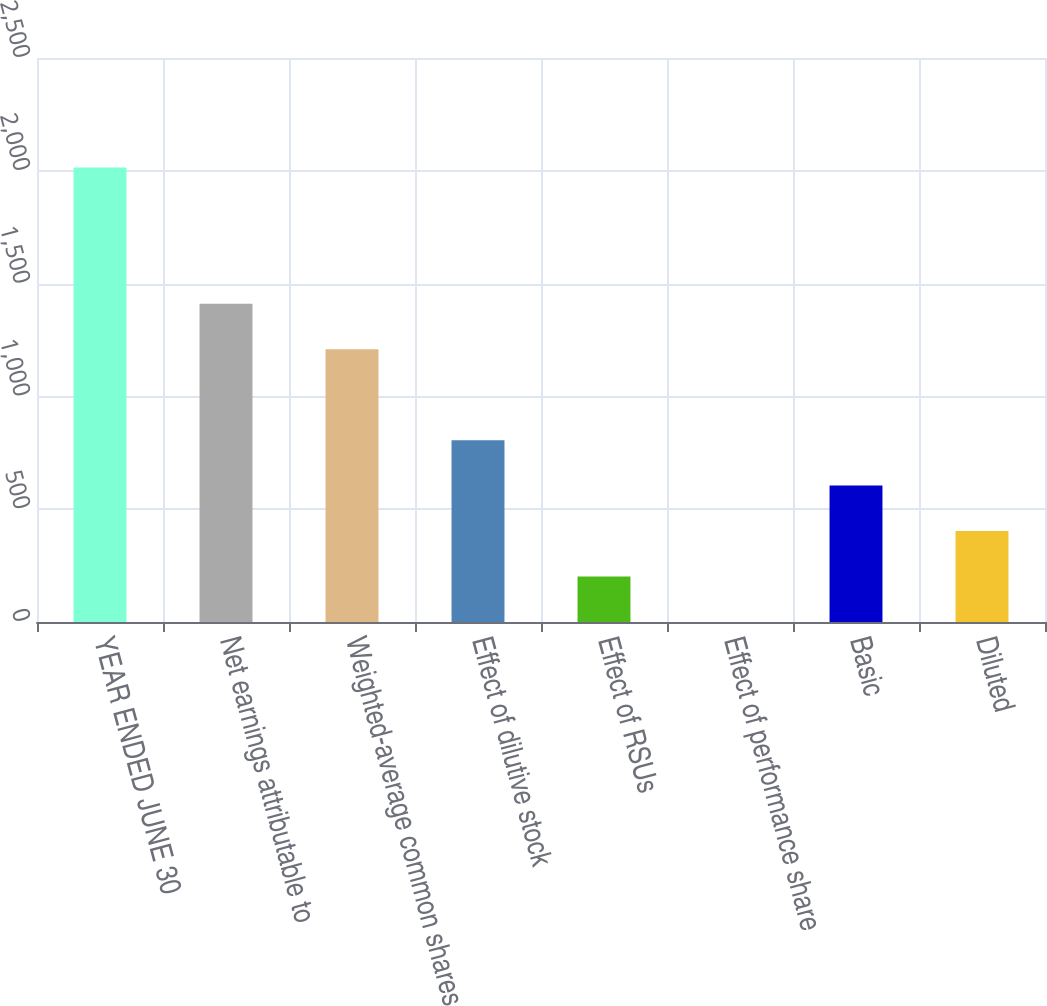Convert chart to OTSL. <chart><loc_0><loc_0><loc_500><loc_500><bar_chart><fcel>YEAR ENDED JUNE 30<fcel>Net earnings attributable to<fcel>Weighted-average common shares<fcel>Effect of dilutive stock<fcel>Effect of RSUs<fcel>Effect of performance share<fcel>Basic<fcel>Diluted<nl><fcel>2015<fcel>1410.53<fcel>1209.04<fcel>806.06<fcel>201.59<fcel>0.1<fcel>604.57<fcel>403.08<nl></chart> 